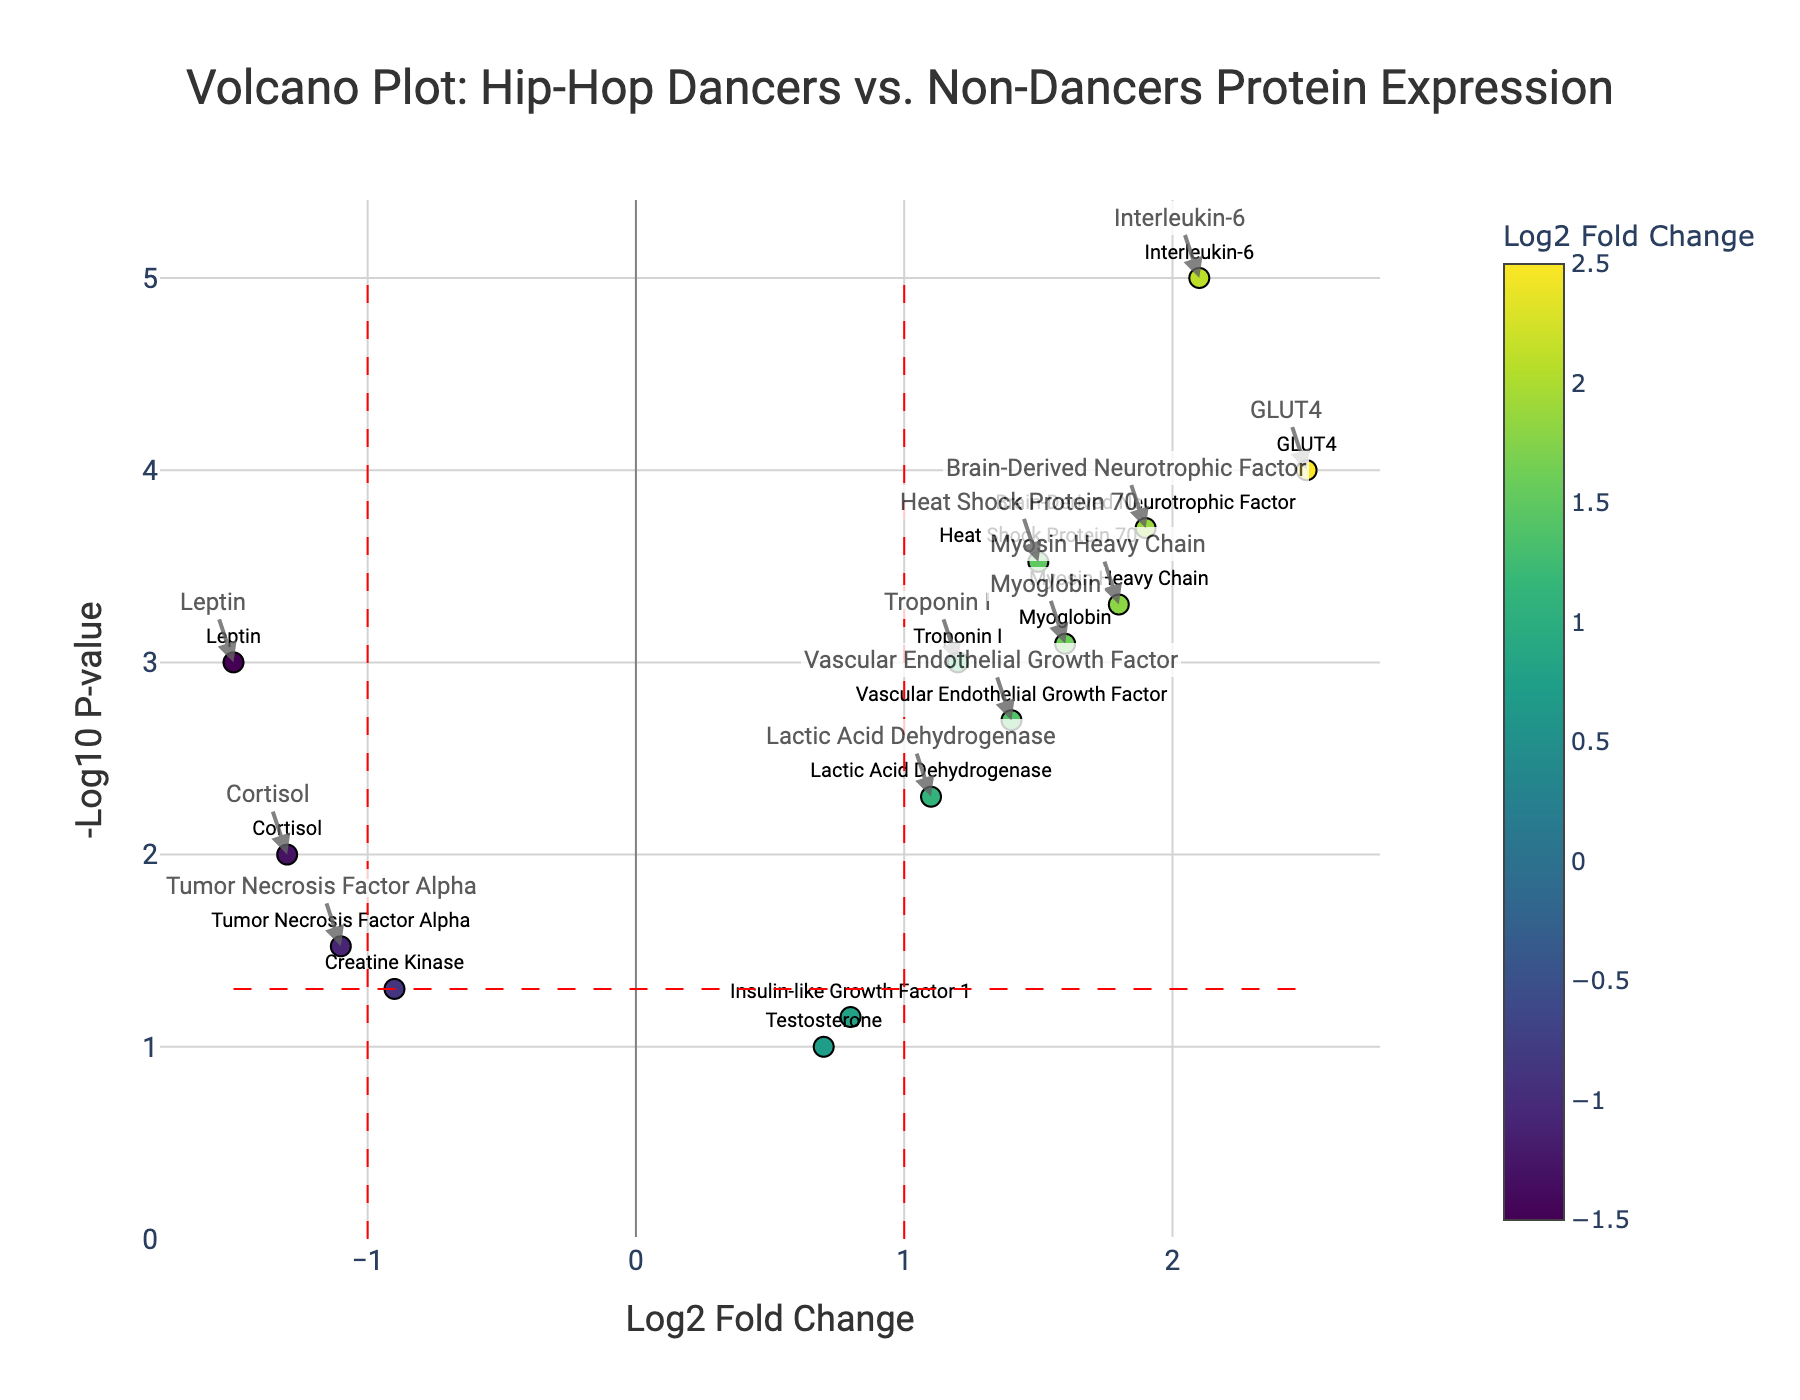What is the title of the plot? The title of the plot is displayed at the top center of the figure. It reads "Volcano Plot: Hip-Hop Dancers vs. Non-Dancers Protein Expression"
Answer: Volcano Plot: Hip-Hop Dancers vs. Non-Dancers Protein Expression What are the axes' labels? The x-axis label is "Log2 Fold Change," and the y-axis label is "-Log10 P-value." These are visible at the bottom and left side of the plot respectively
Answer: Log2 Fold Change, -Log10 P-value How many proteins are shown on the plot? To find the number of proteins, count the number of markers on the plot. There are 15 markers representing 15 proteins
Answer: 15 Which protein has the highest Log2 Fold Change? The highest Log2 Fold Change is the marker farthest to the right on the x-axis. The protein name next to the rightmost marker is "GLUT4," which has a Log2 Fold Change of 2.5
Answer: GLUT4 Which protein has the lowest p-value? The lowest p-value corresponds to the highest -Log10 P-value (highest point on the y-axis). The protein at the highest position on the y-axis is "Interleukin-6"
Answer: Interleukin-6 Name two proteins with a negative Log2 Fold Change and a significant p-value First, look for markers left of the vertical line at Log2 Fold Change = -1 that are also above the horizontal significance threshold line. "Cortisol" and "Leptin" fit these criteria with negative Log2 Fold Change values and significant p-values
Answer: Cortisol, Leptin Which protein has a Log2 Fold Change close to 1.5 and a significant p-value? Find the protein marker closest to the x value of 1.5 and above the horizontal significance line. "Heat Shock Protein 70" has a Log2 Fold Change of 1.5 and falls above the threshold line for p-value significance
Answer: Heat Shock Protein 70 How many proteins have a positive Log2 Fold Change and significant p-values? Count the number of markers right of the vertical Log2 Fold Change = 1 line and above the horizontal significance line. There are 8 such proteins
Answer: 8 What is the approximate p-value for the protein "Myoglobin"? Locate the "Myoglobin" marker and follow horizontally to the -Log10 P-value on the y-axis. "Myoglobin" is between 3 and 4, so approximately its p-value is around 10^(-3.5)
Answer: Approximately 0.0003 Which protein has a significant increase in expression and plays a role in muscle contraction? Review the annotated protein names and their biological roles. "Myosin Heavy Chain" is significant and involved in muscle contraction
Answer: Myosin Heavy Chain 